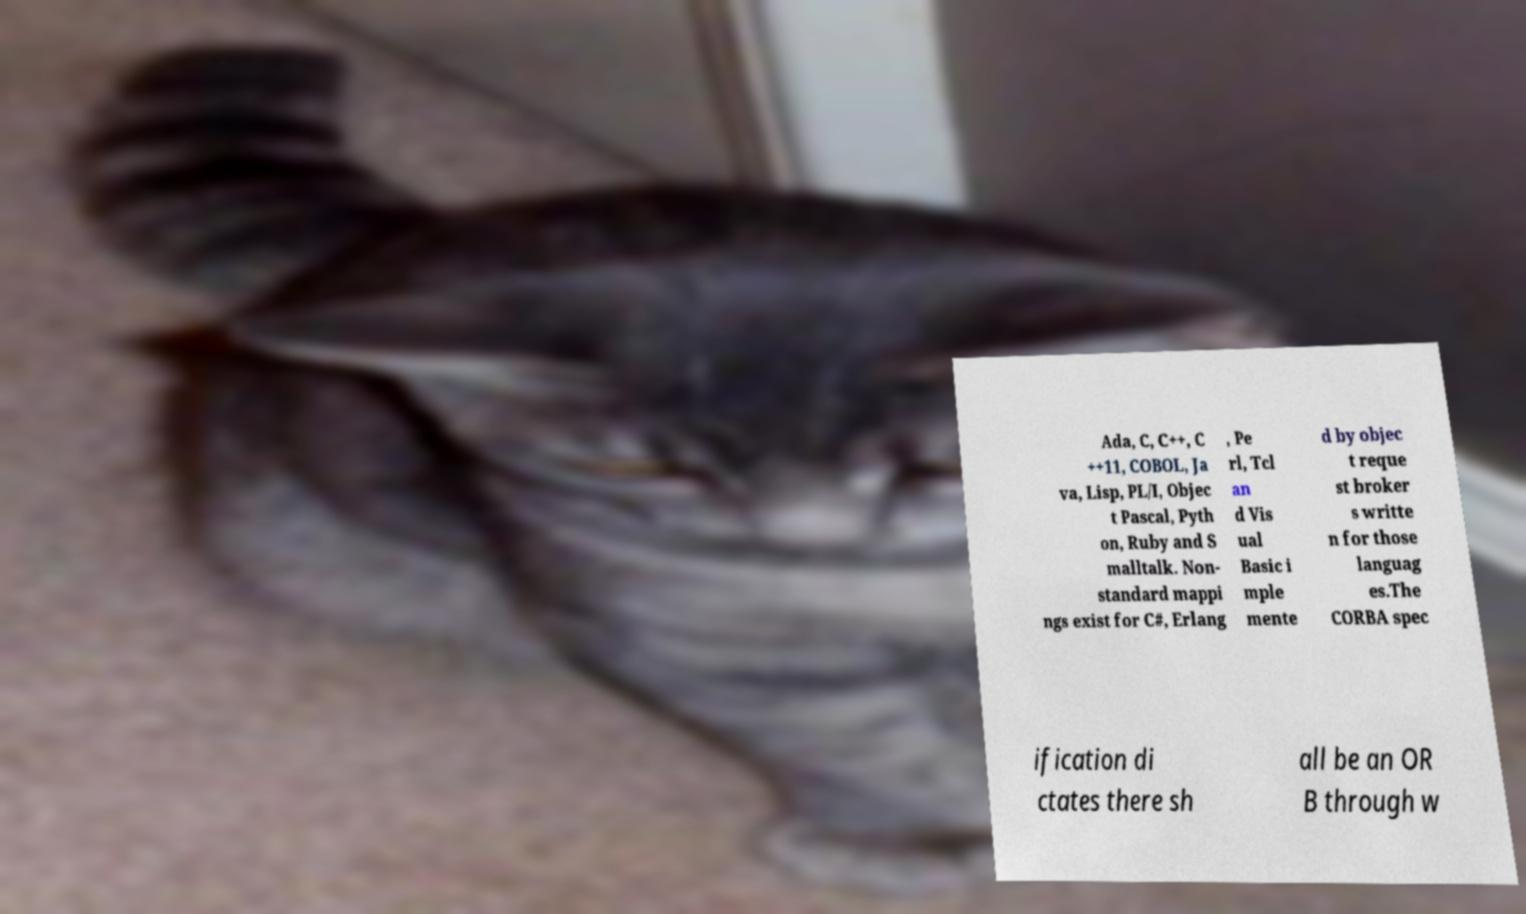Can you accurately transcribe the text from the provided image for me? Ada, C, C++, C ++11, COBOL, Ja va, Lisp, PL/I, Objec t Pascal, Pyth on, Ruby and S malltalk. Non- standard mappi ngs exist for C#, Erlang , Pe rl, Tcl an d Vis ual Basic i mple mente d by objec t reque st broker s writte n for those languag es.The CORBA spec ification di ctates there sh all be an OR B through w 